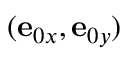<formula> <loc_0><loc_0><loc_500><loc_500>( e _ { 0 x } , e _ { 0 y } )</formula> 